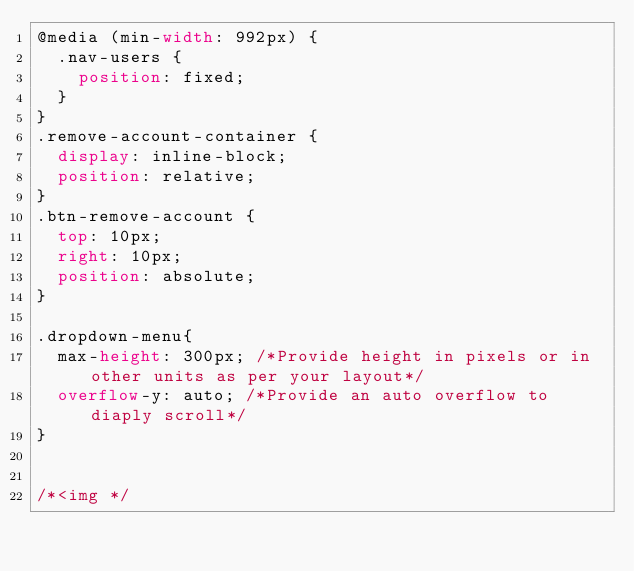Convert code to text. <code><loc_0><loc_0><loc_500><loc_500><_CSS_>@media (min-width: 992px) {
	.nav-users {
		position: fixed;
	}
}
.remove-account-container {
	display: inline-block;
	position: relative;
}
.btn-remove-account {
	top: 10px;
	right: 10px;
	position: absolute;
}

.dropdown-menu{
	max-height: 300px; /*Provide height in pixels or in other units as per your layout*/
	overflow-y: auto; /*Provide an auto overflow to diaply scroll*/
}


/*<img */</code> 